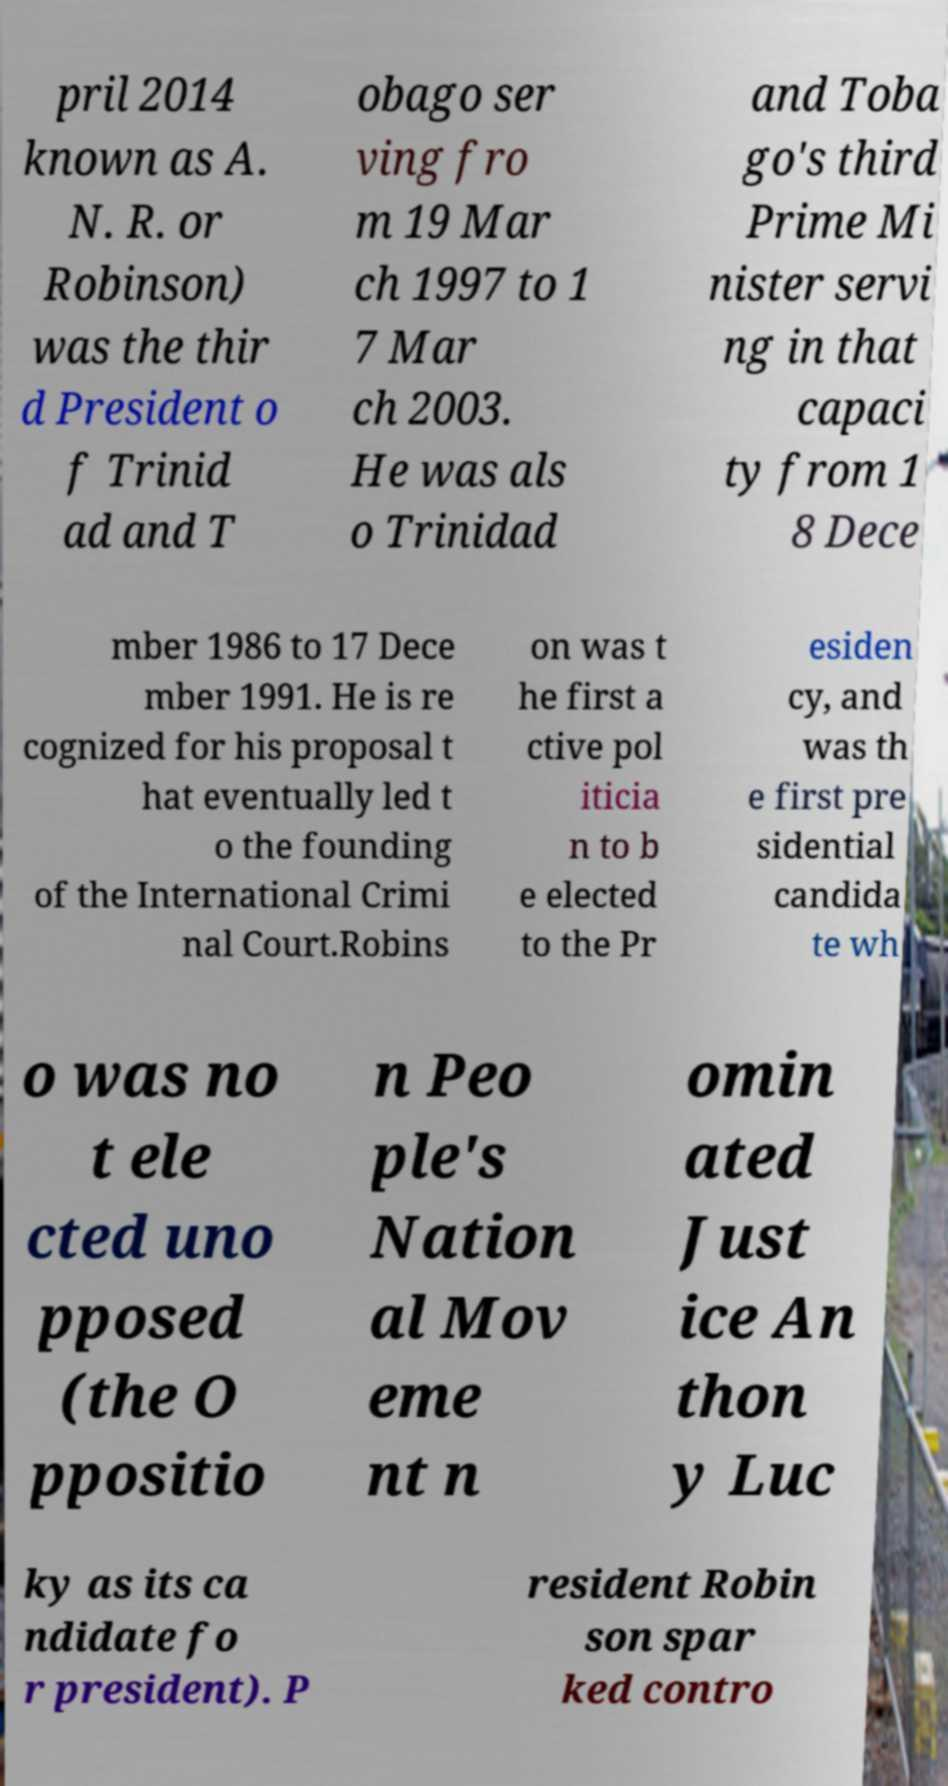What messages or text are displayed in this image? I need them in a readable, typed format. pril 2014 known as A. N. R. or Robinson) was the thir d President o f Trinid ad and T obago ser ving fro m 19 Mar ch 1997 to 1 7 Mar ch 2003. He was als o Trinidad and Toba go's third Prime Mi nister servi ng in that capaci ty from 1 8 Dece mber 1986 to 17 Dece mber 1991. He is re cognized for his proposal t hat eventually led t o the founding of the International Crimi nal Court.Robins on was t he first a ctive pol iticia n to b e elected to the Pr esiden cy, and was th e first pre sidential candida te wh o was no t ele cted uno pposed (the O ppositio n Peo ple's Nation al Mov eme nt n omin ated Just ice An thon y Luc ky as its ca ndidate fo r president). P resident Robin son spar ked contro 